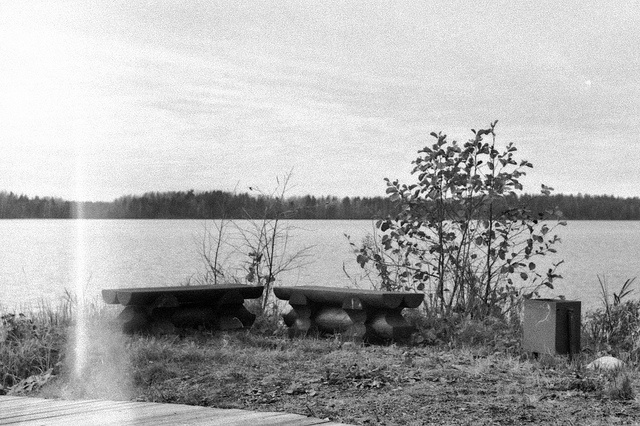Describe the objects in this image and their specific colors. I can see bench in white, black, gray, and lightgray tones and bench in white, black, gray, darkgray, and lightgray tones in this image. 